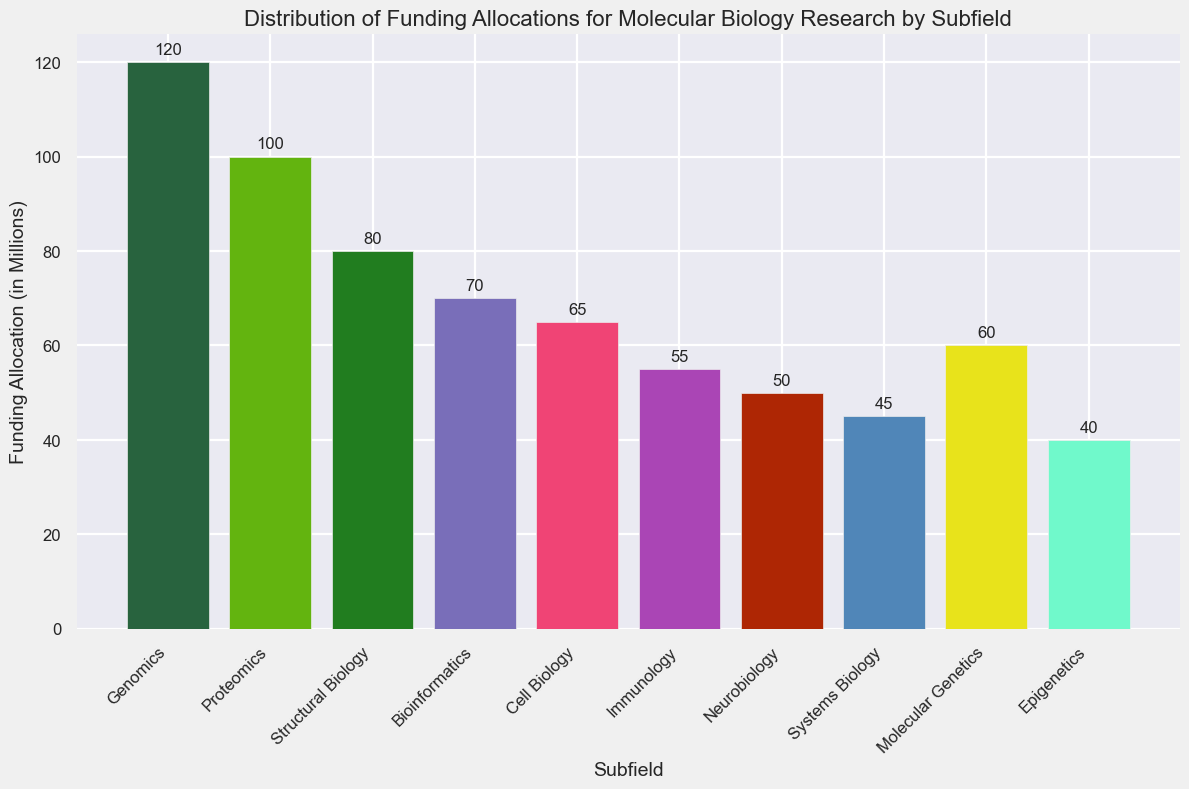What is the total funding allocation for the combined subfields of Neurobiology and Immunology? Sum the funding allocations for Neurobiology and Immunology: 50 (Neurobiology) + 55 (Immunology) = 105.
Answer: 105 Which subfield has the highest funding allocation? Identify the subfield with the tallest bar in the chart, which represents the highest funding allocation. This is Genomics with a value of 120.
Answer: Genomics How much more funding does Genomics receive compared to Epigenetics? Subtract the funding allocation for Epigenetics from Genomics: 120 (Genomics) - 40 (Epigenetics) = 80.
Answer: 80 What is the average funding allocation across all subfields? Sum all the funding allocations and divide by the number of subfields: (120 + 100 + 80 + 70 + 65 + 55 + 50 + 45 + 60 + 40) / 10 = 685 / 10 = 68.5.
Answer: 68.5 Which subfields have funding allocations below 50 million? Identify the subfields with funding allocations less than 50: Epigenetics (40), Systems Biology (45), Neurobiology (50; does not count as it is equal to 50).
Answer: Epigenetics, Systems Biology How much funding is allocated to Bioinformatics relative to Structural Biology? Subtract the funding allocation for Bioinformatics from Structural Biology: 80 (Structural Biology) - 70 (Bioinformatics) = 10.
Answer: 10 What is the combined funding allocation for the top three funded subfields? Sum the funding allocations of the top three subfields: Genomics (120), Proteomics (100), and Structural Biology (80): 120 + 100 + 80 = 300.
Answer: 300 Between Cell Biology and Molecular Genetics, which one has a higher funding allocation, and by how much? Subtract the funding allocation for Molecular Genetics from Cell Biology: 65 (Cell Biology) - 60 (Molecular Genetics) = 5.
Answer: Cell Biology, 5 How much funding is allocated to the subfield with the lowest funding allocation? Identify the subfield with the shortest bar, which is Epigenetics with a value of 40.
Answer: 40 